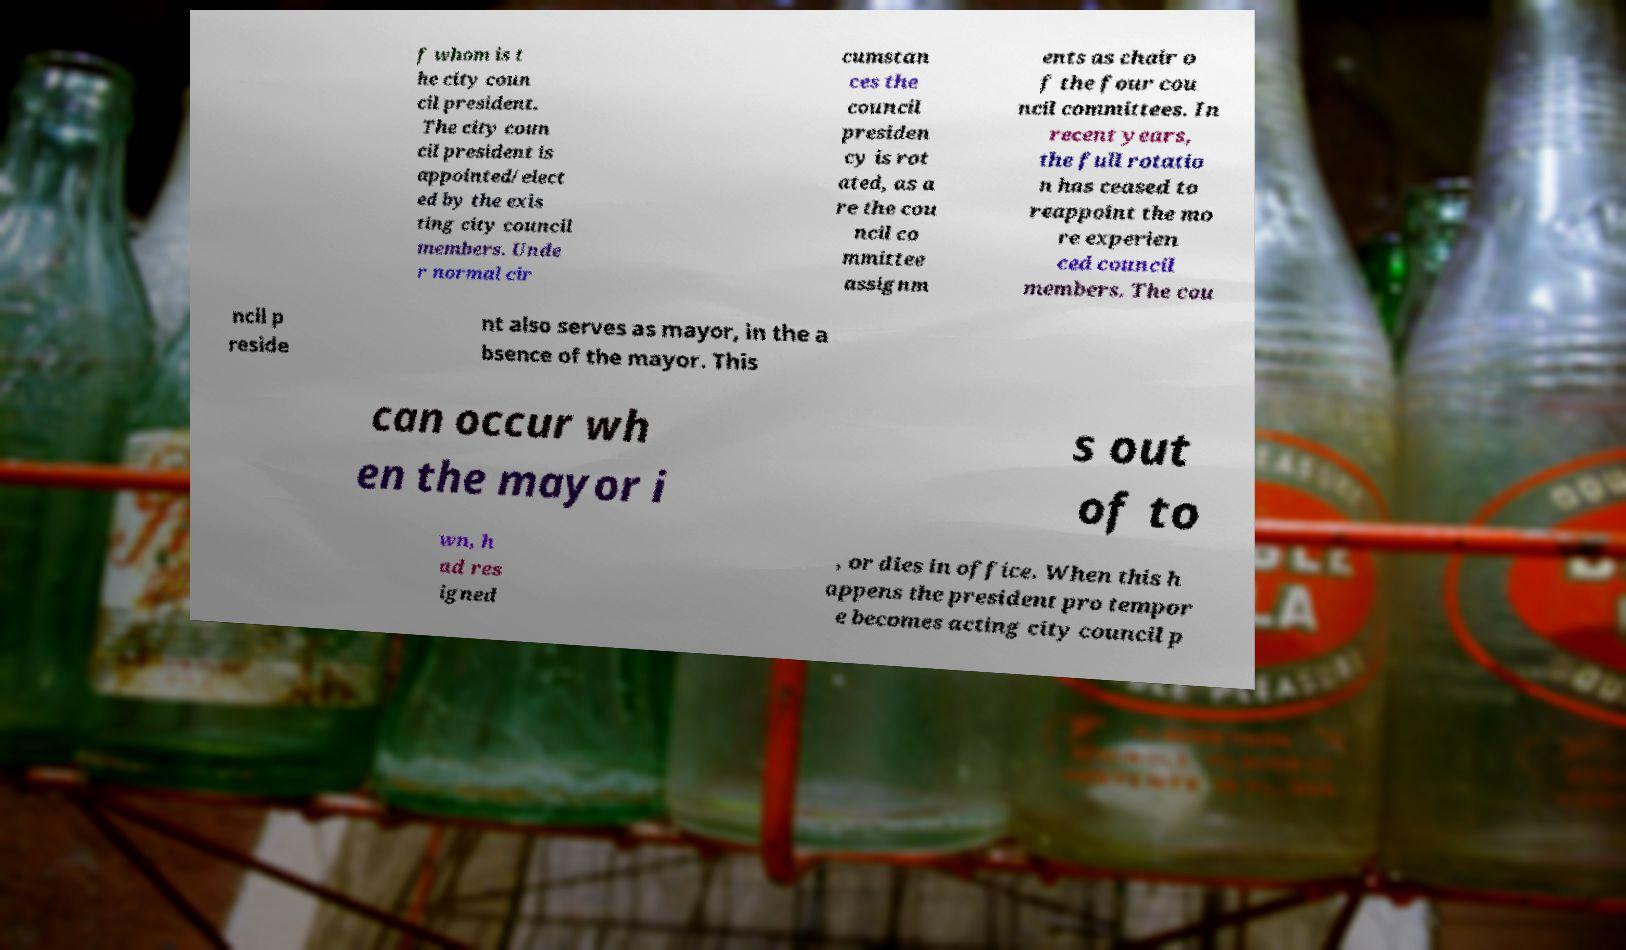Can you read and provide the text displayed in the image?This photo seems to have some interesting text. Can you extract and type it out for me? f whom is t he city coun cil president. The city coun cil president is appointed/elect ed by the exis ting city council members. Unde r normal cir cumstan ces the council presiden cy is rot ated, as a re the cou ncil co mmittee assignm ents as chair o f the four cou ncil committees. In recent years, the full rotatio n has ceased to reappoint the mo re experien ced council members. The cou ncil p reside nt also serves as mayor, in the a bsence of the mayor. This can occur wh en the mayor i s out of to wn, h ad res igned , or dies in office. When this h appens the president pro tempor e becomes acting city council p 